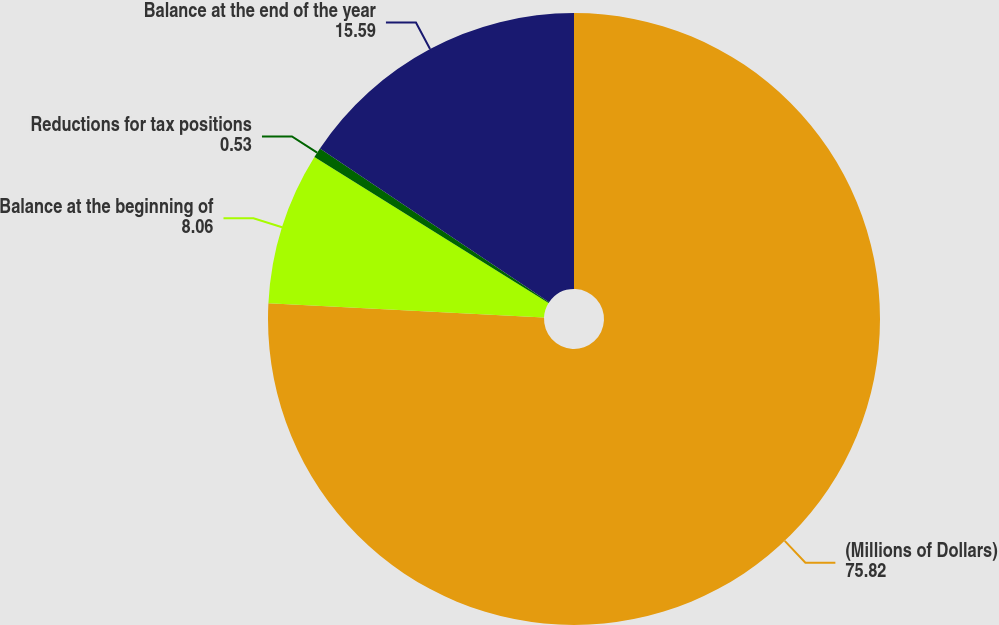Convert chart. <chart><loc_0><loc_0><loc_500><loc_500><pie_chart><fcel>(Millions of Dollars)<fcel>Balance at the beginning of<fcel>Reductions for tax positions<fcel>Balance at the end of the year<nl><fcel>75.82%<fcel>8.06%<fcel>0.53%<fcel>15.59%<nl></chart> 